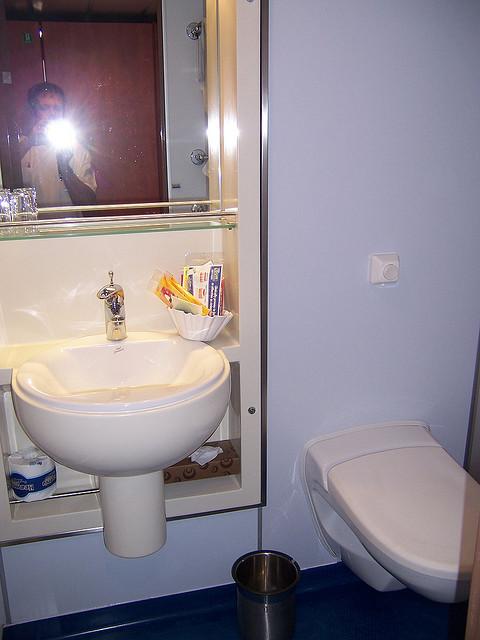What room is shown?
Concise answer only. Bathroom. What kind of sink is under the mirror?
Concise answer only. Baby holstein. Is the toilet lid shut or open?
Answer briefly. Shut. 